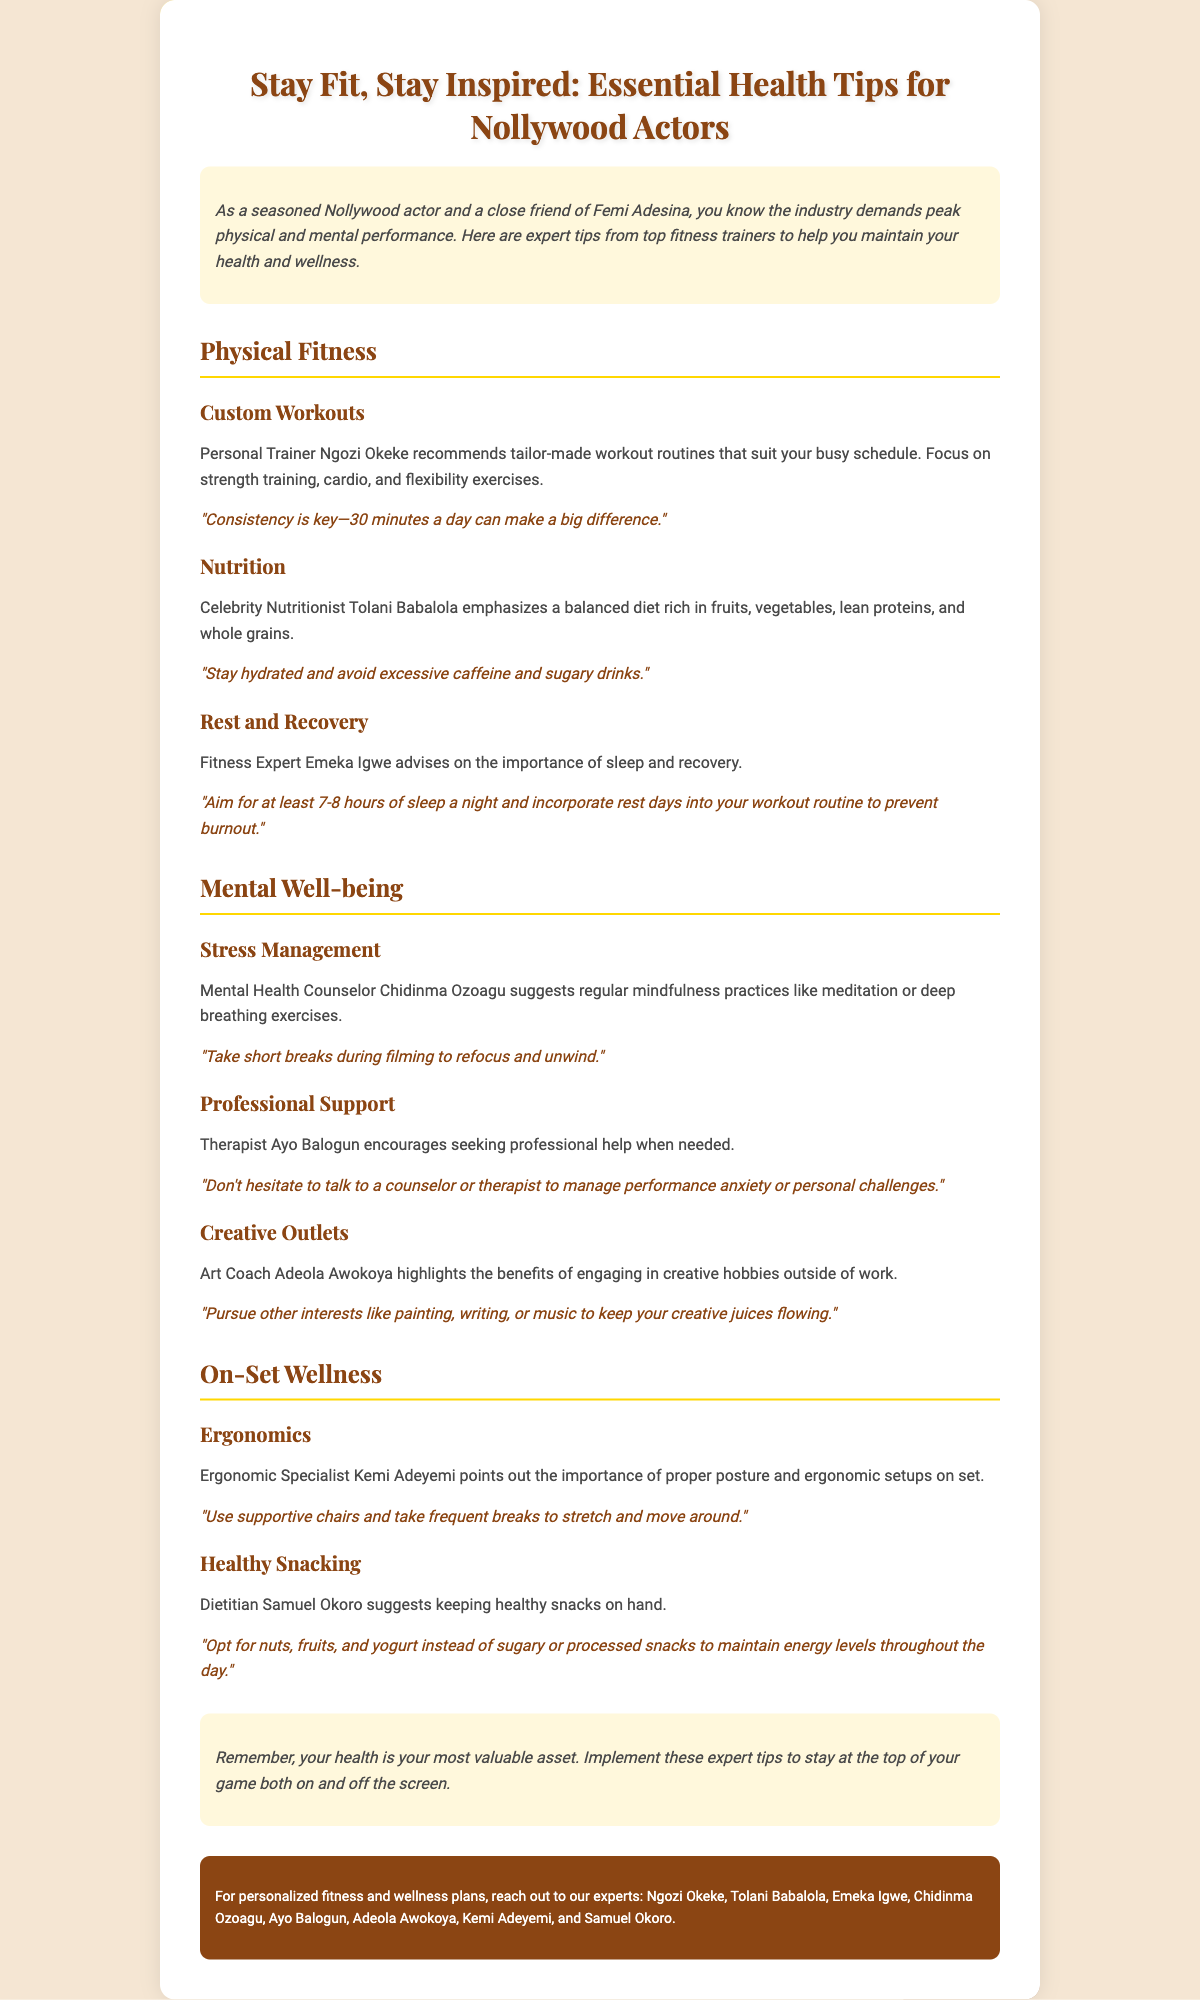What is the title of the flyer? The title is prominently displayed at the top of the flyer.
Answer: Stay Fit, Stay Inspired: Essential Health Tips for Nollywood Actors Who is the personal trainer mentioned for custom workouts? The flyer lists a personal trainer who advises on workouts.
Answer: Ngozi Okeke What does the fitness expert emphasize regarding sleep? The flyer provides specific advice from experts about sleep.
Answer: Aim for at least 7-8 hours of sleep a night Which practice is suggested for stress management? The flyer includes recommendations for mental well-being practices.
Answer: Mindfulness practices like meditation What type of snacks does the dietitian recommend keeping on hand? The flyer specifies healthy snack alternatives for actors.
Answer: Nuts, fruits, and yogurt What is a notable quote about consistency in workouts? The flyer contains motivational quotes related to fitness routines.
Answer: "Consistency is key—30 minutes a day can make a big difference." Who encourages seeking professional help for managing anxiety? The flyer attributes advice to a mental health professional regarding anxiety.
Answer: Ayo Balogun What is the overall message at the end of the flyer? The closing section summarizes the essence of maintaining health.
Answer: Your health is your most valuable asset 